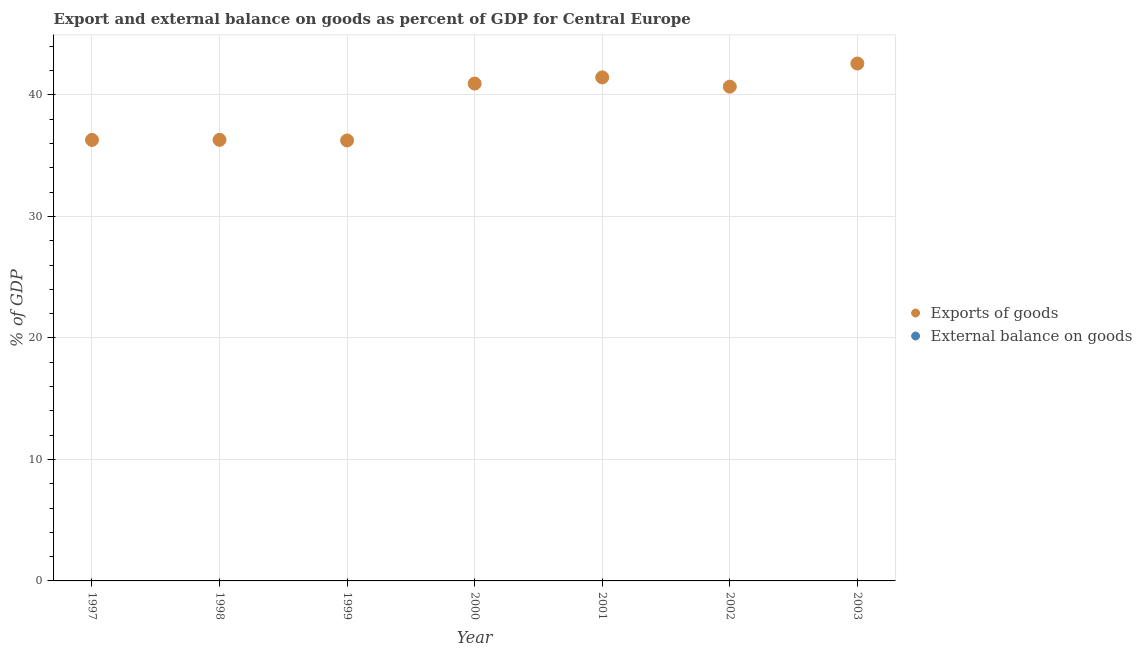Is the number of dotlines equal to the number of legend labels?
Keep it short and to the point. No. Across all years, what is the maximum export of goods as percentage of gdp?
Offer a terse response. 42.59. Across all years, what is the minimum export of goods as percentage of gdp?
Make the answer very short. 36.26. What is the total external balance on goods as percentage of gdp in the graph?
Your response must be concise. 0. What is the difference between the export of goods as percentage of gdp in 2002 and that in 2003?
Give a very brief answer. -1.9. What is the difference between the export of goods as percentage of gdp in 2001 and the external balance on goods as percentage of gdp in 2002?
Offer a terse response. 41.45. What is the average export of goods as percentage of gdp per year?
Provide a short and direct response. 39.22. What is the ratio of the export of goods as percentage of gdp in 1998 to that in 2000?
Your response must be concise. 0.89. What is the difference between the highest and the second highest export of goods as percentage of gdp?
Your answer should be very brief. 1.14. What is the difference between the highest and the lowest export of goods as percentage of gdp?
Ensure brevity in your answer.  6.33. In how many years, is the external balance on goods as percentage of gdp greater than the average external balance on goods as percentage of gdp taken over all years?
Your response must be concise. 0. How many dotlines are there?
Ensure brevity in your answer.  1. How many years are there in the graph?
Provide a succinct answer. 7. What is the difference between two consecutive major ticks on the Y-axis?
Provide a succinct answer. 10. Are the values on the major ticks of Y-axis written in scientific E-notation?
Make the answer very short. No. Does the graph contain any zero values?
Offer a very short reply. Yes. Does the graph contain grids?
Ensure brevity in your answer.  Yes. How are the legend labels stacked?
Your answer should be compact. Vertical. What is the title of the graph?
Keep it short and to the point. Export and external balance on goods as percent of GDP for Central Europe. Does "Merchandise exports" appear as one of the legend labels in the graph?
Provide a short and direct response. No. What is the label or title of the X-axis?
Offer a terse response. Year. What is the label or title of the Y-axis?
Provide a short and direct response. % of GDP. What is the % of GDP of Exports of goods in 1997?
Give a very brief answer. 36.3. What is the % of GDP in External balance on goods in 1997?
Ensure brevity in your answer.  0. What is the % of GDP of Exports of goods in 1998?
Offer a terse response. 36.31. What is the % of GDP in Exports of goods in 1999?
Make the answer very short. 36.26. What is the % of GDP in Exports of goods in 2000?
Offer a very short reply. 40.94. What is the % of GDP of Exports of goods in 2001?
Offer a very short reply. 41.45. What is the % of GDP of External balance on goods in 2001?
Keep it short and to the point. 0. What is the % of GDP in Exports of goods in 2002?
Provide a succinct answer. 40.69. What is the % of GDP in Exports of goods in 2003?
Offer a very short reply. 42.59. What is the % of GDP in External balance on goods in 2003?
Your answer should be very brief. 0. Across all years, what is the maximum % of GDP in Exports of goods?
Offer a terse response. 42.59. Across all years, what is the minimum % of GDP in Exports of goods?
Offer a terse response. 36.26. What is the total % of GDP in Exports of goods in the graph?
Make the answer very short. 274.53. What is the total % of GDP in External balance on goods in the graph?
Ensure brevity in your answer.  0. What is the difference between the % of GDP of Exports of goods in 1997 and that in 1998?
Offer a very short reply. -0.01. What is the difference between the % of GDP of Exports of goods in 1997 and that in 1999?
Give a very brief answer. 0.04. What is the difference between the % of GDP in Exports of goods in 1997 and that in 2000?
Keep it short and to the point. -4.64. What is the difference between the % of GDP in Exports of goods in 1997 and that in 2001?
Provide a short and direct response. -5.15. What is the difference between the % of GDP in Exports of goods in 1997 and that in 2002?
Ensure brevity in your answer.  -4.38. What is the difference between the % of GDP of Exports of goods in 1997 and that in 2003?
Make the answer very short. -6.29. What is the difference between the % of GDP in Exports of goods in 1998 and that in 1999?
Offer a terse response. 0.05. What is the difference between the % of GDP in Exports of goods in 1998 and that in 2000?
Your answer should be very brief. -4.63. What is the difference between the % of GDP of Exports of goods in 1998 and that in 2001?
Your answer should be very brief. -5.14. What is the difference between the % of GDP of Exports of goods in 1998 and that in 2002?
Your answer should be compact. -4.38. What is the difference between the % of GDP in Exports of goods in 1998 and that in 2003?
Ensure brevity in your answer.  -6.28. What is the difference between the % of GDP in Exports of goods in 1999 and that in 2000?
Give a very brief answer. -4.68. What is the difference between the % of GDP in Exports of goods in 1999 and that in 2001?
Keep it short and to the point. -5.19. What is the difference between the % of GDP of Exports of goods in 1999 and that in 2002?
Ensure brevity in your answer.  -4.43. What is the difference between the % of GDP in Exports of goods in 1999 and that in 2003?
Your response must be concise. -6.33. What is the difference between the % of GDP in Exports of goods in 2000 and that in 2001?
Your answer should be compact. -0.51. What is the difference between the % of GDP in Exports of goods in 2000 and that in 2002?
Your answer should be very brief. 0.25. What is the difference between the % of GDP in Exports of goods in 2000 and that in 2003?
Your answer should be compact. -1.65. What is the difference between the % of GDP of Exports of goods in 2001 and that in 2002?
Offer a very short reply. 0.76. What is the difference between the % of GDP of Exports of goods in 2001 and that in 2003?
Offer a terse response. -1.14. What is the difference between the % of GDP in Exports of goods in 2002 and that in 2003?
Your answer should be compact. -1.9. What is the average % of GDP in Exports of goods per year?
Provide a succinct answer. 39.22. What is the average % of GDP in External balance on goods per year?
Keep it short and to the point. 0. What is the ratio of the % of GDP in Exports of goods in 1997 to that in 1998?
Your answer should be compact. 1. What is the ratio of the % of GDP in Exports of goods in 1997 to that in 1999?
Provide a succinct answer. 1. What is the ratio of the % of GDP of Exports of goods in 1997 to that in 2000?
Offer a terse response. 0.89. What is the ratio of the % of GDP of Exports of goods in 1997 to that in 2001?
Provide a succinct answer. 0.88. What is the ratio of the % of GDP of Exports of goods in 1997 to that in 2002?
Provide a short and direct response. 0.89. What is the ratio of the % of GDP in Exports of goods in 1997 to that in 2003?
Offer a terse response. 0.85. What is the ratio of the % of GDP of Exports of goods in 1998 to that in 2000?
Make the answer very short. 0.89. What is the ratio of the % of GDP in Exports of goods in 1998 to that in 2001?
Make the answer very short. 0.88. What is the ratio of the % of GDP of Exports of goods in 1998 to that in 2002?
Provide a short and direct response. 0.89. What is the ratio of the % of GDP of Exports of goods in 1998 to that in 2003?
Your response must be concise. 0.85. What is the ratio of the % of GDP in Exports of goods in 1999 to that in 2000?
Offer a very short reply. 0.89. What is the ratio of the % of GDP in Exports of goods in 1999 to that in 2001?
Keep it short and to the point. 0.87. What is the ratio of the % of GDP of Exports of goods in 1999 to that in 2002?
Offer a terse response. 0.89. What is the ratio of the % of GDP of Exports of goods in 1999 to that in 2003?
Offer a very short reply. 0.85. What is the ratio of the % of GDP of Exports of goods in 2000 to that in 2001?
Give a very brief answer. 0.99. What is the ratio of the % of GDP of Exports of goods in 2000 to that in 2002?
Make the answer very short. 1.01. What is the ratio of the % of GDP in Exports of goods in 2000 to that in 2003?
Offer a terse response. 0.96. What is the ratio of the % of GDP of Exports of goods in 2001 to that in 2002?
Keep it short and to the point. 1.02. What is the ratio of the % of GDP of Exports of goods in 2001 to that in 2003?
Provide a succinct answer. 0.97. What is the ratio of the % of GDP in Exports of goods in 2002 to that in 2003?
Provide a succinct answer. 0.96. What is the difference between the highest and the second highest % of GDP of Exports of goods?
Your response must be concise. 1.14. What is the difference between the highest and the lowest % of GDP in Exports of goods?
Keep it short and to the point. 6.33. 